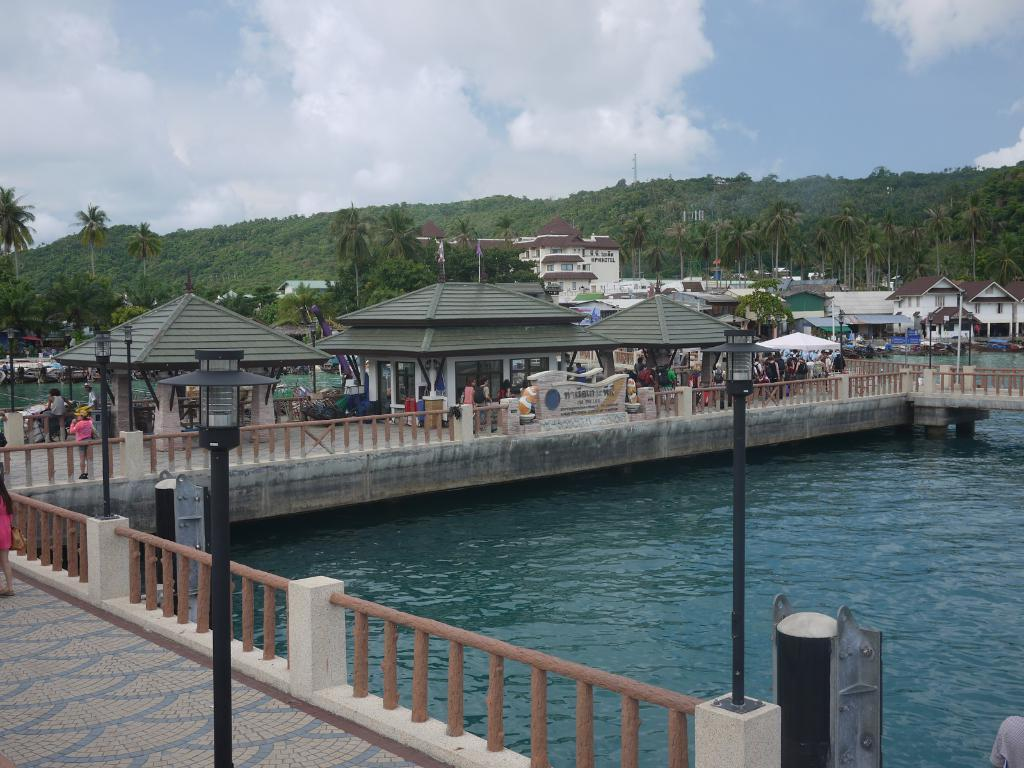What type of water body is visible in the image? There is a big river in the image. What structure is present over the river? There is a bridge in the image. What are people doing on the bridge? People are standing on the bridge. What additional structure is present on the bridge? There is a tent on the bridge. What geographical feature is visible in the background? There is a mountain in the image. What type of vegetation is present on the mountain? Trees are present on the mountain. What type of man-made structures can be seen in the image? There are buildings in the image. What type of tail can be seen on the mountain in the image? There is no tail present on the mountain in the image. What type of mine is visible in the image? There is no mine present in the image. 